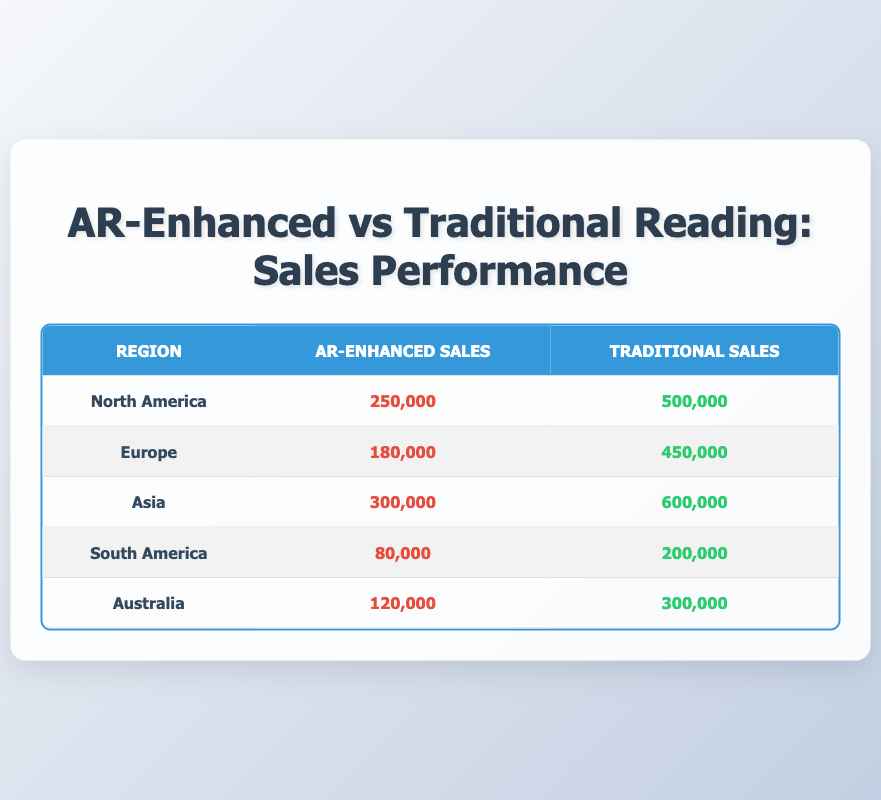What are the AR-enhanced sales in North America? The table shows that the AR-enhanced sales in North America are listed as 250,000.
Answer: 250,000 What is the total traditional sales across all regions? To find the total traditional sales, we add the sales from each region: 500,000 + 450,000 + 600,000 + 200,000 + 300,000 = 2,100,000.
Answer: 2,100,000 Did Asia have higher AR-enhanced sales than South America? The AR-enhanced sales for Asia are 300,000 and for South America are 80,000, which confirms that Asia had higher sales than South America.
Answer: Yes Which region had the lowest AR-enhanced sales? By comparing the AR-enhanced sales figures, the lowest is 80,000 from South America, while the others are higher.
Answer: South America What is the difference between traditional sales in North America and Europe? The difference is calculated by subtracting the traditional sales in Europe from those in North America: 500,000 - 450,000 = 50,000.
Answer: 50,000 Is the ratio of AR-enhanced sales to traditional sales higher in Australia than in South America? For Australia, the ratio is 120,000/300,000 = 0.4, while for South America it is 80,000/200,000 = 0.4. Since both ratios are equal, Australia does not have a higher ratio.
Answer: No What is the average AR-enhanced sales across all regions? The total AR-enhanced sales are 250,000 + 180,000 + 300,000 + 80,000 + 120,000 = 930,000. We divide this by the number of regions (5): 930,000 / 5 = 186,000.
Answer: 186,000 Which region has the highest sales in total (AR-enhanced + traditional)? We calculate the total sales for each region: North America (750,000), Europe (630,000), Asia (900,000), South America (280,000), Australia (420,000). Asia has the highest total at 900,000.
Answer: Asia How many regions have AR-enhanced sales above 200,000? The regions with sales above 200,000 are North America (250,000), Asia (300,000), which makes a total of 2 regions.
Answer: 2 